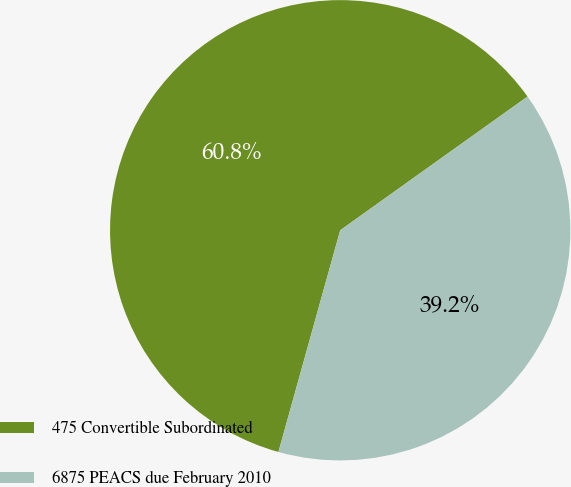Convert chart. <chart><loc_0><loc_0><loc_500><loc_500><pie_chart><fcel>475 Convertible Subordinated<fcel>6875 PEACS due February 2010<nl><fcel>60.81%<fcel>39.19%<nl></chart> 